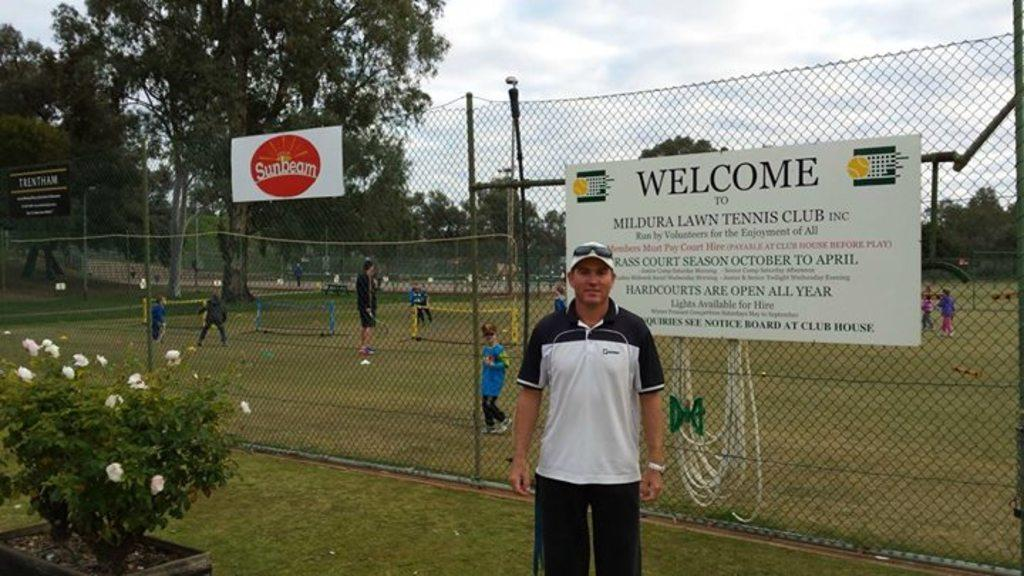Provide a one-sentence caption for the provided image. A big sign welcoming people to Mildura Lawn Tennis Club hands from a fence. 